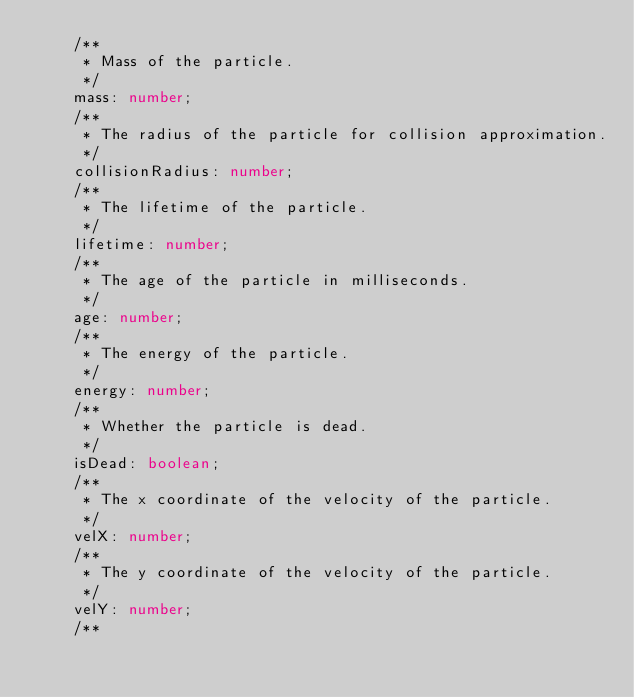Convert code to text. <code><loc_0><loc_0><loc_500><loc_500><_TypeScript_>    /**
     * Mass of the particle.
     */
    mass: number;
    /**
     * The radius of the particle for collision approximation.
     */
    collisionRadius: number;
    /**
     * The lifetime of the particle.
     */
    lifetime: number;
    /**
     * The age of the particle in milliseconds.
     */
    age: number;
    /**
     * The energy of the particle.
     */
    energy: number;
    /**
     * Whether the particle is dead.
     */
    isDead: boolean;
    /**
     * The x coordinate of the velocity of the particle.
     */
    velX: number;
    /**
     * The y coordinate of the velocity of the particle.
     */
    velY: number;
    /**</code> 